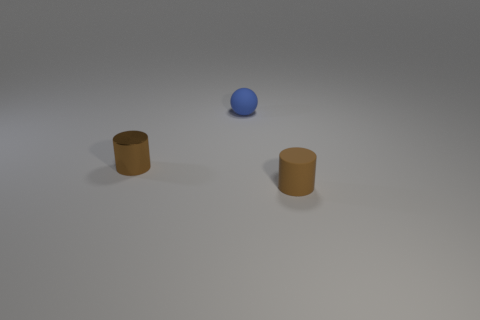Add 3 small blue matte objects. How many objects exist? 6 Subtract all matte objects. Subtract all spheres. How many objects are left? 0 Add 1 small brown shiny objects. How many small brown shiny objects are left? 2 Add 3 brown matte objects. How many brown matte objects exist? 4 Subtract 0 cyan blocks. How many objects are left? 3 Subtract all cylinders. How many objects are left? 1 